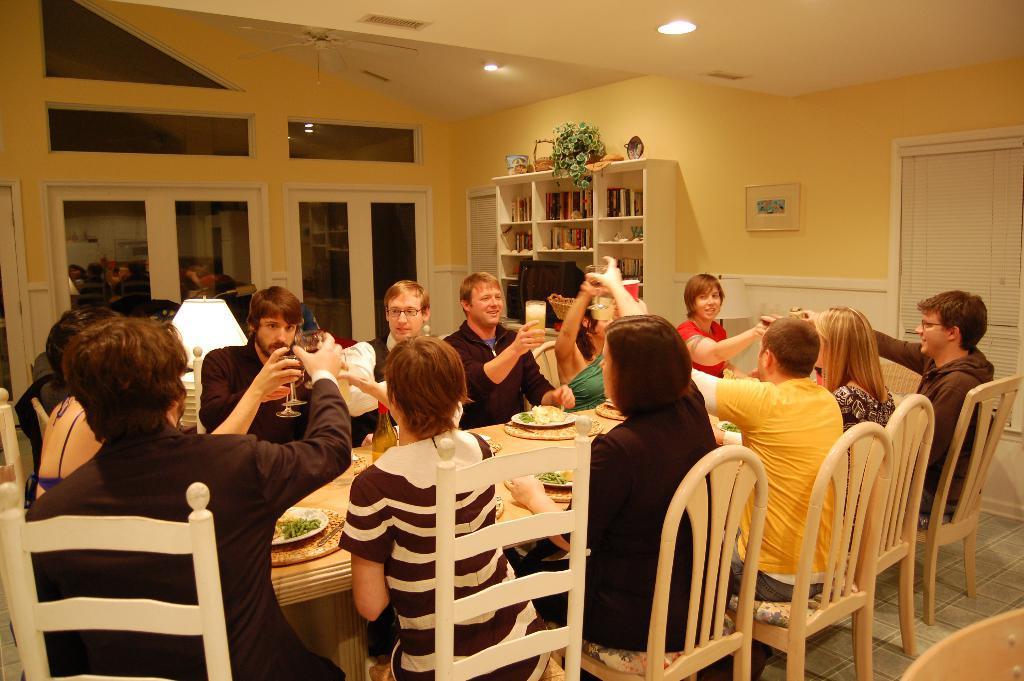Describe this image in one or two sentences. In this picture we can see a group of people sitting on chair and in front of them there is table and on table we can see plates food in it, bottle and this persons are holding glass in their hands and in background we can see window, racks with books in it, plant, wall with frame. 